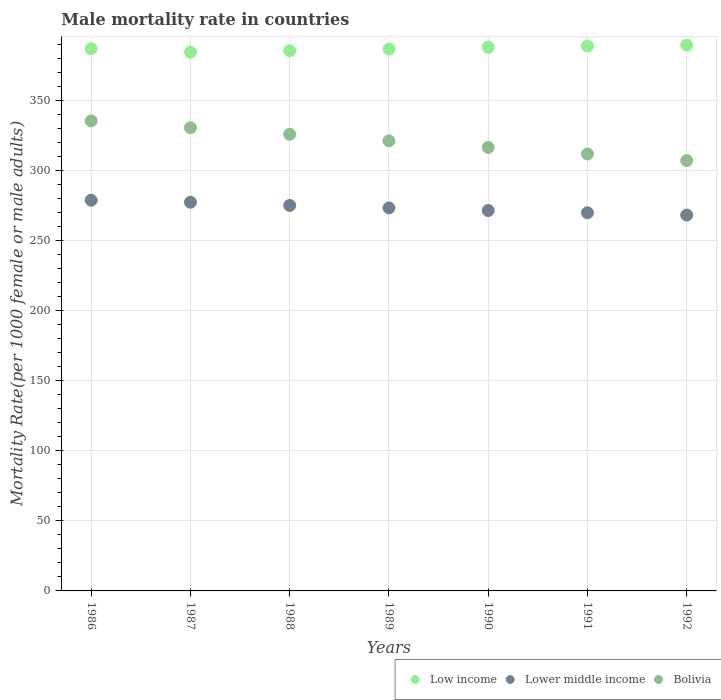Is the number of dotlines equal to the number of legend labels?
Keep it short and to the point. Yes. What is the male mortality rate in Lower middle income in 1986?
Your answer should be compact. 278.89. Across all years, what is the maximum male mortality rate in Bolivia?
Provide a short and direct response. 335.51. Across all years, what is the minimum male mortality rate in Bolivia?
Ensure brevity in your answer.  307.18. What is the total male mortality rate in Lower middle income in the graph?
Provide a succinct answer. 1914.64. What is the difference between the male mortality rate in Lower middle income in 1990 and that in 1991?
Offer a very short reply. 1.62. What is the difference between the male mortality rate in Lower middle income in 1988 and the male mortality rate in Bolivia in 1990?
Make the answer very short. -41.44. What is the average male mortality rate in Lower middle income per year?
Provide a short and direct response. 273.52. In the year 1988, what is the difference between the male mortality rate in Lower middle income and male mortality rate in Low income?
Offer a very short reply. -110.45. What is the ratio of the male mortality rate in Bolivia in 1986 to that in 1991?
Offer a terse response. 1.08. Is the male mortality rate in Low income in 1987 less than that in 1988?
Keep it short and to the point. Yes. Is the difference between the male mortality rate in Lower middle income in 1988 and 1989 greater than the difference between the male mortality rate in Low income in 1988 and 1989?
Provide a succinct answer. Yes. What is the difference between the highest and the second highest male mortality rate in Low income?
Offer a very short reply. 0.69. What is the difference between the highest and the lowest male mortality rate in Bolivia?
Keep it short and to the point. 28.33. Is the sum of the male mortality rate in Low income in 1987 and 1992 greater than the maximum male mortality rate in Bolivia across all years?
Keep it short and to the point. Yes. Is it the case that in every year, the sum of the male mortality rate in Bolivia and male mortality rate in Lower middle income  is greater than the male mortality rate in Low income?
Your response must be concise. Yes. Is the male mortality rate in Bolivia strictly less than the male mortality rate in Low income over the years?
Ensure brevity in your answer.  Yes. How many years are there in the graph?
Your answer should be compact. 7. What is the difference between two consecutive major ticks on the Y-axis?
Your answer should be very brief. 50. Are the values on the major ticks of Y-axis written in scientific E-notation?
Your answer should be compact. No. Does the graph contain any zero values?
Offer a terse response. No. Does the graph contain grids?
Provide a succinct answer. Yes. What is the title of the graph?
Ensure brevity in your answer.  Male mortality rate in countries. Does "Tonga" appear as one of the legend labels in the graph?
Give a very brief answer. No. What is the label or title of the Y-axis?
Offer a terse response. Mortality Rate(per 1000 female or male adults). What is the Mortality Rate(per 1000 female or male adults) in Low income in 1986?
Make the answer very short. 386.95. What is the Mortality Rate(per 1000 female or male adults) of Lower middle income in 1986?
Offer a very short reply. 278.89. What is the Mortality Rate(per 1000 female or male adults) in Bolivia in 1986?
Offer a very short reply. 335.51. What is the Mortality Rate(per 1000 female or male adults) of Low income in 1987?
Your response must be concise. 384.53. What is the Mortality Rate(per 1000 female or male adults) in Lower middle income in 1987?
Your answer should be compact. 277.45. What is the Mortality Rate(per 1000 female or male adults) of Bolivia in 1987?
Provide a succinct answer. 330.66. What is the Mortality Rate(per 1000 female or male adults) in Low income in 1988?
Your answer should be very brief. 385.59. What is the Mortality Rate(per 1000 female or male adults) in Lower middle income in 1988?
Provide a succinct answer. 275.14. What is the Mortality Rate(per 1000 female or male adults) of Bolivia in 1988?
Provide a succinct answer. 325.96. What is the Mortality Rate(per 1000 female or male adults) of Low income in 1989?
Offer a terse response. 386.79. What is the Mortality Rate(per 1000 female or male adults) of Lower middle income in 1989?
Your answer should be compact. 273.4. What is the Mortality Rate(per 1000 female or male adults) in Bolivia in 1989?
Your answer should be very brief. 321.27. What is the Mortality Rate(per 1000 female or male adults) in Low income in 1990?
Ensure brevity in your answer.  388.08. What is the Mortality Rate(per 1000 female or male adults) in Lower middle income in 1990?
Give a very brief answer. 271.54. What is the Mortality Rate(per 1000 female or male adults) in Bolivia in 1990?
Your response must be concise. 316.57. What is the Mortality Rate(per 1000 female or male adults) of Low income in 1991?
Ensure brevity in your answer.  388.94. What is the Mortality Rate(per 1000 female or male adults) of Lower middle income in 1991?
Offer a very short reply. 269.92. What is the Mortality Rate(per 1000 female or male adults) in Bolivia in 1991?
Your answer should be very brief. 311.88. What is the Mortality Rate(per 1000 female or male adults) in Low income in 1992?
Your response must be concise. 389.63. What is the Mortality Rate(per 1000 female or male adults) of Lower middle income in 1992?
Your response must be concise. 268.3. What is the Mortality Rate(per 1000 female or male adults) of Bolivia in 1992?
Offer a terse response. 307.18. Across all years, what is the maximum Mortality Rate(per 1000 female or male adults) in Low income?
Provide a succinct answer. 389.63. Across all years, what is the maximum Mortality Rate(per 1000 female or male adults) of Lower middle income?
Provide a succinct answer. 278.89. Across all years, what is the maximum Mortality Rate(per 1000 female or male adults) of Bolivia?
Provide a succinct answer. 335.51. Across all years, what is the minimum Mortality Rate(per 1000 female or male adults) in Low income?
Offer a terse response. 384.53. Across all years, what is the minimum Mortality Rate(per 1000 female or male adults) of Lower middle income?
Your response must be concise. 268.3. Across all years, what is the minimum Mortality Rate(per 1000 female or male adults) in Bolivia?
Give a very brief answer. 307.18. What is the total Mortality Rate(per 1000 female or male adults) in Low income in the graph?
Offer a terse response. 2710.5. What is the total Mortality Rate(per 1000 female or male adults) in Lower middle income in the graph?
Offer a terse response. 1914.64. What is the total Mortality Rate(per 1000 female or male adults) of Bolivia in the graph?
Your response must be concise. 2249.03. What is the difference between the Mortality Rate(per 1000 female or male adults) in Low income in 1986 and that in 1987?
Provide a short and direct response. 2.41. What is the difference between the Mortality Rate(per 1000 female or male adults) of Lower middle income in 1986 and that in 1987?
Offer a very short reply. 1.44. What is the difference between the Mortality Rate(per 1000 female or male adults) of Bolivia in 1986 and that in 1987?
Your answer should be very brief. 4.86. What is the difference between the Mortality Rate(per 1000 female or male adults) in Low income in 1986 and that in 1988?
Offer a very short reply. 1.36. What is the difference between the Mortality Rate(per 1000 female or male adults) of Lower middle income in 1986 and that in 1988?
Your response must be concise. 3.75. What is the difference between the Mortality Rate(per 1000 female or male adults) of Bolivia in 1986 and that in 1988?
Provide a succinct answer. 9.55. What is the difference between the Mortality Rate(per 1000 female or male adults) of Low income in 1986 and that in 1989?
Your answer should be compact. 0.16. What is the difference between the Mortality Rate(per 1000 female or male adults) of Lower middle income in 1986 and that in 1989?
Give a very brief answer. 5.49. What is the difference between the Mortality Rate(per 1000 female or male adults) of Bolivia in 1986 and that in 1989?
Your answer should be very brief. 14.24. What is the difference between the Mortality Rate(per 1000 female or male adults) in Low income in 1986 and that in 1990?
Give a very brief answer. -1.13. What is the difference between the Mortality Rate(per 1000 female or male adults) in Lower middle income in 1986 and that in 1990?
Your response must be concise. 7.35. What is the difference between the Mortality Rate(per 1000 female or male adults) in Bolivia in 1986 and that in 1990?
Give a very brief answer. 18.94. What is the difference between the Mortality Rate(per 1000 female or male adults) in Low income in 1986 and that in 1991?
Your response must be concise. -1.99. What is the difference between the Mortality Rate(per 1000 female or male adults) in Lower middle income in 1986 and that in 1991?
Your answer should be very brief. 8.96. What is the difference between the Mortality Rate(per 1000 female or male adults) of Bolivia in 1986 and that in 1991?
Offer a very short reply. 23.63. What is the difference between the Mortality Rate(per 1000 female or male adults) in Low income in 1986 and that in 1992?
Make the answer very short. -2.68. What is the difference between the Mortality Rate(per 1000 female or male adults) in Lower middle income in 1986 and that in 1992?
Give a very brief answer. 10.59. What is the difference between the Mortality Rate(per 1000 female or male adults) of Bolivia in 1986 and that in 1992?
Your response must be concise. 28.33. What is the difference between the Mortality Rate(per 1000 female or male adults) of Low income in 1987 and that in 1988?
Make the answer very short. -1.05. What is the difference between the Mortality Rate(per 1000 female or male adults) of Lower middle income in 1987 and that in 1988?
Offer a very short reply. 2.31. What is the difference between the Mortality Rate(per 1000 female or male adults) in Bolivia in 1987 and that in 1988?
Provide a succinct answer. 4.7. What is the difference between the Mortality Rate(per 1000 female or male adults) in Low income in 1987 and that in 1989?
Offer a very short reply. -2.26. What is the difference between the Mortality Rate(per 1000 female or male adults) in Lower middle income in 1987 and that in 1989?
Offer a terse response. 4.05. What is the difference between the Mortality Rate(per 1000 female or male adults) of Bolivia in 1987 and that in 1989?
Keep it short and to the point. 9.39. What is the difference between the Mortality Rate(per 1000 female or male adults) of Low income in 1987 and that in 1990?
Offer a terse response. -3.54. What is the difference between the Mortality Rate(per 1000 female or male adults) of Lower middle income in 1987 and that in 1990?
Make the answer very short. 5.9. What is the difference between the Mortality Rate(per 1000 female or male adults) in Bolivia in 1987 and that in 1990?
Offer a terse response. 14.08. What is the difference between the Mortality Rate(per 1000 female or male adults) in Low income in 1987 and that in 1991?
Keep it short and to the point. -4.4. What is the difference between the Mortality Rate(per 1000 female or male adults) in Lower middle income in 1987 and that in 1991?
Your answer should be very brief. 7.52. What is the difference between the Mortality Rate(per 1000 female or male adults) in Bolivia in 1987 and that in 1991?
Your answer should be very brief. 18.78. What is the difference between the Mortality Rate(per 1000 female or male adults) in Low income in 1987 and that in 1992?
Provide a succinct answer. -5.09. What is the difference between the Mortality Rate(per 1000 female or male adults) in Lower middle income in 1987 and that in 1992?
Your response must be concise. 9.14. What is the difference between the Mortality Rate(per 1000 female or male adults) in Bolivia in 1987 and that in 1992?
Provide a succinct answer. 23.47. What is the difference between the Mortality Rate(per 1000 female or male adults) of Low income in 1988 and that in 1989?
Offer a terse response. -1.2. What is the difference between the Mortality Rate(per 1000 female or male adults) in Lower middle income in 1988 and that in 1989?
Give a very brief answer. 1.74. What is the difference between the Mortality Rate(per 1000 female or male adults) in Bolivia in 1988 and that in 1989?
Make the answer very short. 4.69. What is the difference between the Mortality Rate(per 1000 female or male adults) in Low income in 1988 and that in 1990?
Your answer should be compact. -2.49. What is the difference between the Mortality Rate(per 1000 female or male adults) in Lower middle income in 1988 and that in 1990?
Offer a very short reply. 3.59. What is the difference between the Mortality Rate(per 1000 female or male adults) of Bolivia in 1988 and that in 1990?
Provide a succinct answer. 9.39. What is the difference between the Mortality Rate(per 1000 female or male adults) in Low income in 1988 and that in 1991?
Give a very brief answer. -3.35. What is the difference between the Mortality Rate(per 1000 female or male adults) in Lower middle income in 1988 and that in 1991?
Keep it short and to the point. 5.21. What is the difference between the Mortality Rate(per 1000 female or male adults) in Bolivia in 1988 and that in 1991?
Provide a succinct answer. 14.08. What is the difference between the Mortality Rate(per 1000 female or male adults) in Low income in 1988 and that in 1992?
Give a very brief answer. -4.04. What is the difference between the Mortality Rate(per 1000 female or male adults) in Lower middle income in 1988 and that in 1992?
Provide a succinct answer. 6.83. What is the difference between the Mortality Rate(per 1000 female or male adults) of Bolivia in 1988 and that in 1992?
Make the answer very short. 18.78. What is the difference between the Mortality Rate(per 1000 female or male adults) in Low income in 1989 and that in 1990?
Keep it short and to the point. -1.28. What is the difference between the Mortality Rate(per 1000 female or male adults) in Lower middle income in 1989 and that in 1990?
Your answer should be compact. 1.86. What is the difference between the Mortality Rate(per 1000 female or male adults) of Bolivia in 1989 and that in 1990?
Offer a terse response. 4.69. What is the difference between the Mortality Rate(per 1000 female or male adults) of Low income in 1989 and that in 1991?
Offer a very short reply. -2.15. What is the difference between the Mortality Rate(per 1000 female or male adults) of Lower middle income in 1989 and that in 1991?
Keep it short and to the point. 3.48. What is the difference between the Mortality Rate(per 1000 female or male adults) of Bolivia in 1989 and that in 1991?
Your answer should be compact. 9.39. What is the difference between the Mortality Rate(per 1000 female or male adults) of Low income in 1989 and that in 1992?
Ensure brevity in your answer.  -2.84. What is the difference between the Mortality Rate(per 1000 female or male adults) of Lower middle income in 1989 and that in 1992?
Ensure brevity in your answer.  5.1. What is the difference between the Mortality Rate(per 1000 female or male adults) of Bolivia in 1989 and that in 1992?
Provide a short and direct response. 14.08. What is the difference between the Mortality Rate(per 1000 female or male adults) of Low income in 1990 and that in 1991?
Your answer should be compact. -0.86. What is the difference between the Mortality Rate(per 1000 female or male adults) in Lower middle income in 1990 and that in 1991?
Keep it short and to the point. 1.62. What is the difference between the Mortality Rate(per 1000 female or male adults) in Bolivia in 1990 and that in 1991?
Offer a terse response. 4.7. What is the difference between the Mortality Rate(per 1000 female or male adults) of Low income in 1990 and that in 1992?
Make the answer very short. -1.55. What is the difference between the Mortality Rate(per 1000 female or male adults) of Lower middle income in 1990 and that in 1992?
Give a very brief answer. 3.24. What is the difference between the Mortality Rate(per 1000 female or male adults) of Bolivia in 1990 and that in 1992?
Ensure brevity in your answer.  9.39. What is the difference between the Mortality Rate(per 1000 female or male adults) in Low income in 1991 and that in 1992?
Your answer should be compact. -0.69. What is the difference between the Mortality Rate(per 1000 female or male adults) of Lower middle income in 1991 and that in 1992?
Your response must be concise. 1.62. What is the difference between the Mortality Rate(per 1000 female or male adults) in Bolivia in 1991 and that in 1992?
Your response must be concise. 4.69. What is the difference between the Mortality Rate(per 1000 female or male adults) of Low income in 1986 and the Mortality Rate(per 1000 female or male adults) of Lower middle income in 1987?
Offer a terse response. 109.5. What is the difference between the Mortality Rate(per 1000 female or male adults) of Low income in 1986 and the Mortality Rate(per 1000 female or male adults) of Bolivia in 1987?
Offer a terse response. 56.29. What is the difference between the Mortality Rate(per 1000 female or male adults) of Lower middle income in 1986 and the Mortality Rate(per 1000 female or male adults) of Bolivia in 1987?
Your response must be concise. -51.77. What is the difference between the Mortality Rate(per 1000 female or male adults) of Low income in 1986 and the Mortality Rate(per 1000 female or male adults) of Lower middle income in 1988?
Offer a very short reply. 111.81. What is the difference between the Mortality Rate(per 1000 female or male adults) in Low income in 1986 and the Mortality Rate(per 1000 female or male adults) in Bolivia in 1988?
Ensure brevity in your answer.  60.99. What is the difference between the Mortality Rate(per 1000 female or male adults) of Lower middle income in 1986 and the Mortality Rate(per 1000 female or male adults) of Bolivia in 1988?
Give a very brief answer. -47.07. What is the difference between the Mortality Rate(per 1000 female or male adults) in Low income in 1986 and the Mortality Rate(per 1000 female or male adults) in Lower middle income in 1989?
Keep it short and to the point. 113.55. What is the difference between the Mortality Rate(per 1000 female or male adults) of Low income in 1986 and the Mortality Rate(per 1000 female or male adults) of Bolivia in 1989?
Ensure brevity in your answer.  65.68. What is the difference between the Mortality Rate(per 1000 female or male adults) of Lower middle income in 1986 and the Mortality Rate(per 1000 female or male adults) of Bolivia in 1989?
Your answer should be very brief. -42.38. What is the difference between the Mortality Rate(per 1000 female or male adults) of Low income in 1986 and the Mortality Rate(per 1000 female or male adults) of Lower middle income in 1990?
Your answer should be very brief. 115.41. What is the difference between the Mortality Rate(per 1000 female or male adults) of Low income in 1986 and the Mortality Rate(per 1000 female or male adults) of Bolivia in 1990?
Keep it short and to the point. 70.38. What is the difference between the Mortality Rate(per 1000 female or male adults) in Lower middle income in 1986 and the Mortality Rate(per 1000 female or male adults) in Bolivia in 1990?
Offer a very short reply. -37.68. What is the difference between the Mortality Rate(per 1000 female or male adults) in Low income in 1986 and the Mortality Rate(per 1000 female or male adults) in Lower middle income in 1991?
Your answer should be very brief. 117.02. What is the difference between the Mortality Rate(per 1000 female or male adults) in Low income in 1986 and the Mortality Rate(per 1000 female or male adults) in Bolivia in 1991?
Your response must be concise. 75.07. What is the difference between the Mortality Rate(per 1000 female or male adults) of Lower middle income in 1986 and the Mortality Rate(per 1000 female or male adults) of Bolivia in 1991?
Keep it short and to the point. -32.99. What is the difference between the Mortality Rate(per 1000 female or male adults) of Low income in 1986 and the Mortality Rate(per 1000 female or male adults) of Lower middle income in 1992?
Keep it short and to the point. 118.65. What is the difference between the Mortality Rate(per 1000 female or male adults) in Low income in 1986 and the Mortality Rate(per 1000 female or male adults) in Bolivia in 1992?
Ensure brevity in your answer.  79.77. What is the difference between the Mortality Rate(per 1000 female or male adults) in Lower middle income in 1986 and the Mortality Rate(per 1000 female or male adults) in Bolivia in 1992?
Ensure brevity in your answer.  -28.3. What is the difference between the Mortality Rate(per 1000 female or male adults) of Low income in 1987 and the Mortality Rate(per 1000 female or male adults) of Lower middle income in 1988?
Your answer should be compact. 109.4. What is the difference between the Mortality Rate(per 1000 female or male adults) of Low income in 1987 and the Mortality Rate(per 1000 female or male adults) of Bolivia in 1988?
Provide a short and direct response. 58.57. What is the difference between the Mortality Rate(per 1000 female or male adults) in Lower middle income in 1987 and the Mortality Rate(per 1000 female or male adults) in Bolivia in 1988?
Your response must be concise. -48.51. What is the difference between the Mortality Rate(per 1000 female or male adults) in Low income in 1987 and the Mortality Rate(per 1000 female or male adults) in Lower middle income in 1989?
Give a very brief answer. 111.13. What is the difference between the Mortality Rate(per 1000 female or male adults) in Low income in 1987 and the Mortality Rate(per 1000 female or male adults) in Bolivia in 1989?
Your response must be concise. 63.27. What is the difference between the Mortality Rate(per 1000 female or male adults) in Lower middle income in 1987 and the Mortality Rate(per 1000 female or male adults) in Bolivia in 1989?
Make the answer very short. -43.82. What is the difference between the Mortality Rate(per 1000 female or male adults) in Low income in 1987 and the Mortality Rate(per 1000 female or male adults) in Lower middle income in 1990?
Offer a terse response. 112.99. What is the difference between the Mortality Rate(per 1000 female or male adults) in Low income in 1987 and the Mortality Rate(per 1000 female or male adults) in Bolivia in 1990?
Provide a short and direct response. 67.96. What is the difference between the Mortality Rate(per 1000 female or male adults) in Lower middle income in 1987 and the Mortality Rate(per 1000 female or male adults) in Bolivia in 1990?
Ensure brevity in your answer.  -39.13. What is the difference between the Mortality Rate(per 1000 female or male adults) of Low income in 1987 and the Mortality Rate(per 1000 female or male adults) of Lower middle income in 1991?
Your response must be concise. 114.61. What is the difference between the Mortality Rate(per 1000 female or male adults) of Low income in 1987 and the Mortality Rate(per 1000 female or male adults) of Bolivia in 1991?
Offer a terse response. 72.66. What is the difference between the Mortality Rate(per 1000 female or male adults) of Lower middle income in 1987 and the Mortality Rate(per 1000 female or male adults) of Bolivia in 1991?
Offer a terse response. -34.43. What is the difference between the Mortality Rate(per 1000 female or male adults) in Low income in 1987 and the Mortality Rate(per 1000 female or male adults) in Lower middle income in 1992?
Provide a short and direct response. 116.23. What is the difference between the Mortality Rate(per 1000 female or male adults) in Low income in 1987 and the Mortality Rate(per 1000 female or male adults) in Bolivia in 1992?
Make the answer very short. 77.35. What is the difference between the Mortality Rate(per 1000 female or male adults) in Lower middle income in 1987 and the Mortality Rate(per 1000 female or male adults) in Bolivia in 1992?
Your answer should be very brief. -29.74. What is the difference between the Mortality Rate(per 1000 female or male adults) of Low income in 1988 and the Mortality Rate(per 1000 female or male adults) of Lower middle income in 1989?
Make the answer very short. 112.19. What is the difference between the Mortality Rate(per 1000 female or male adults) of Low income in 1988 and the Mortality Rate(per 1000 female or male adults) of Bolivia in 1989?
Ensure brevity in your answer.  64.32. What is the difference between the Mortality Rate(per 1000 female or male adults) of Lower middle income in 1988 and the Mortality Rate(per 1000 female or male adults) of Bolivia in 1989?
Offer a very short reply. -46.13. What is the difference between the Mortality Rate(per 1000 female or male adults) in Low income in 1988 and the Mortality Rate(per 1000 female or male adults) in Lower middle income in 1990?
Your answer should be very brief. 114.05. What is the difference between the Mortality Rate(per 1000 female or male adults) in Low income in 1988 and the Mortality Rate(per 1000 female or male adults) in Bolivia in 1990?
Offer a terse response. 69.02. What is the difference between the Mortality Rate(per 1000 female or male adults) of Lower middle income in 1988 and the Mortality Rate(per 1000 female or male adults) of Bolivia in 1990?
Offer a terse response. -41.44. What is the difference between the Mortality Rate(per 1000 female or male adults) in Low income in 1988 and the Mortality Rate(per 1000 female or male adults) in Lower middle income in 1991?
Your answer should be compact. 115.66. What is the difference between the Mortality Rate(per 1000 female or male adults) of Low income in 1988 and the Mortality Rate(per 1000 female or male adults) of Bolivia in 1991?
Your answer should be very brief. 73.71. What is the difference between the Mortality Rate(per 1000 female or male adults) in Lower middle income in 1988 and the Mortality Rate(per 1000 female or male adults) in Bolivia in 1991?
Keep it short and to the point. -36.74. What is the difference between the Mortality Rate(per 1000 female or male adults) of Low income in 1988 and the Mortality Rate(per 1000 female or male adults) of Lower middle income in 1992?
Provide a short and direct response. 117.29. What is the difference between the Mortality Rate(per 1000 female or male adults) in Low income in 1988 and the Mortality Rate(per 1000 female or male adults) in Bolivia in 1992?
Your answer should be compact. 78.4. What is the difference between the Mortality Rate(per 1000 female or male adults) in Lower middle income in 1988 and the Mortality Rate(per 1000 female or male adults) in Bolivia in 1992?
Provide a succinct answer. -32.05. What is the difference between the Mortality Rate(per 1000 female or male adults) in Low income in 1989 and the Mortality Rate(per 1000 female or male adults) in Lower middle income in 1990?
Offer a very short reply. 115.25. What is the difference between the Mortality Rate(per 1000 female or male adults) of Low income in 1989 and the Mortality Rate(per 1000 female or male adults) of Bolivia in 1990?
Your answer should be compact. 70.22. What is the difference between the Mortality Rate(per 1000 female or male adults) of Lower middle income in 1989 and the Mortality Rate(per 1000 female or male adults) of Bolivia in 1990?
Your answer should be very brief. -43.17. What is the difference between the Mortality Rate(per 1000 female or male adults) of Low income in 1989 and the Mortality Rate(per 1000 female or male adults) of Lower middle income in 1991?
Give a very brief answer. 116.87. What is the difference between the Mortality Rate(per 1000 female or male adults) in Low income in 1989 and the Mortality Rate(per 1000 female or male adults) in Bolivia in 1991?
Your answer should be compact. 74.91. What is the difference between the Mortality Rate(per 1000 female or male adults) in Lower middle income in 1989 and the Mortality Rate(per 1000 female or male adults) in Bolivia in 1991?
Make the answer very short. -38.48. What is the difference between the Mortality Rate(per 1000 female or male adults) in Low income in 1989 and the Mortality Rate(per 1000 female or male adults) in Lower middle income in 1992?
Give a very brief answer. 118.49. What is the difference between the Mortality Rate(per 1000 female or male adults) in Low income in 1989 and the Mortality Rate(per 1000 female or male adults) in Bolivia in 1992?
Offer a very short reply. 79.61. What is the difference between the Mortality Rate(per 1000 female or male adults) in Lower middle income in 1989 and the Mortality Rate(per 1000 female or male adults) in Bolivia in 1992?
Provide a succinct answer. -33.78. What is the difference between the Mortality Rate(per 1000 female or male adults) in Low income in 1990 and the Mortality Rate(per 1000 female or male adults) in Lower middle income in 1991?
Make the answer very short. 118.15. What is the difference between the Mortality Rate(per 1000 female or male adults) of Low income in 1990 and the Mortality Rate(per 1000 female or male adults) of Bolivia in 1991?
Provide a succinct answer. 76.2. What is the difference between the Mortality Rate(per 1000 female or male adults) in Lower middle income in 1990 and the Mortality Rate(per 1000 female or male adults) in Bolivia in 1991?
Give a very brief answer. -40.34. What is the difference between the Mortality Rate(per 1000 female or male adults) of Low income in 1990 and the Mortality Rate(per 1000 female or male adults) of Lower middle income in 1992?
Your answer should be very brief. 119.77. What is the difference between the Mortality Rate(per 1000 female or male adults) in Low income in 1990 and the Mortality Rate(per 1000 female or male adults) in Bolivia in 1992?
Keep it short and to the point. 80.89. What is the difference between the Mortality Rate(per 1000 female or male adults) in Lower middle income in 1990 and the Mortality Rate(per 1000 female or male adults) in Bolivia in 1992?
Your answer should be compact. -35.64. What is the difference between the Mortality Rate(per 1000 female or male adults) of Low income in 1991 and the Mortality Rate(per 1000 female or male adults) of Lower middle income in 1992?
Offer a terse response. 120.64. What is the difference between the Mortality Rate(per 1000 female or male adults) in Low income in 1991 and the Mortality Rate(per 1000 female or male adults) in Bolivia in 1992?
Keep it short and to the point. 81.75. What is the difference between the Mortality Rate(per 1000 female or male adults) in Lower middle income in 1991 and the Mortality Rate(per 1000 female or male adults) in Bolivia in 1992?
Keep it short and to the point. -37.26. What is the average Mortality Rate(per 1000 female or male adults) in Low income per year?
Your answer should be compact. 387.21. What is the average Mortality Rate(per 1000 female or male adults) of Lower middle income per year?
Offer a very short reply. 273.52. What is the average Mortality Rate(per 1000 female or male adults) of Bolivia per year?
Provide a short and direct response. 321.29. In the year 1986, what is the difference between the Mortality Rate(per 1000 female or male adults) of Low income and Mortality Rate(per 1000 female or male adults) of Lower middle income?
Offer a very short reply. 108.06. In the year 1986, what is the difference between the Mortality Rate(per 1000 female or male adults) of Low income and Mortality Rate(per 1000 female or male adults) of Bolivia?
Provide a short and direct response. 51.44. In the year 1986, what is the difference between the Mortality Rate(per 1000 female or male adults) in Lower middle income and Mortality Rate(per 1000 female or male adults) in Bolivia?
Give a very brief answer. -56.62. In the year 1987, what is the difference between the Mortality Rate(per 1000 female or male adults) in Low income and Mortality Rate(per 1000 female or male adults) in Lower middle income?
Provide a succinct answer. 107.09. In the year 1987, what is the difference between the Mortality Rate(per 1000 female or male adults) in Low income and Mortality Rate(per 1000 female or male adults) in Bolivia?
Offer a very short reply. 53.88. In the year 1987, what is the difference between the Mortality Rate(per 1000 female or male adults) in Lower middle income and Mortality Rate(per 1000 female or male adults) in Bolivia?
Keep it short and to the point. -53.21. In the year 1988, what is the difference between the Mortality Rate(per 1000 female or male adults) in Low income and Mortality Rate(per 1000 female or male adults) in Lower middle income?
Give a very brief answer. 110.45. In the year 1988, what is the difference between the Mortality Rate(per 1000 female or male adults) of Low income and Mortality Rate(per 1000 female or male adults) of Bolivia?
Keep it short and to the point. 59.63. In the year 1988, what is the difference between the Mortality Rate(per 1000 female or male adults) in Lower middle income and Mortality Rate(per 1000 female or male adults) in Bolivia?
Your answer should be very brief. -50.82. In the year 1989, what is the difference between the Mortality Rate(per 1000 female or male adults) in Low income and Mortality Rate(per 1000 female or male adults) in Lower middle income?
Your answer should be compact. 113.39. In the year 1989, what is the difference between the Mortality Rate(per 1000 female or male adults) of Low income and Mortality Rate(per 1000 female or male adults) of Bolivia?
Your answer should be very brief. 65.52. In the year 1989, what is the difference between the Mortality Rate(per 1000 female or male adults) of Lower middle income and Mortality Rate(per 1000 female or male adults) of Bolivia?
Your answer should be very brief. -47.87. In the year 1990, what is the difference between the Mortality Rate(per 1000 female or male adults) of Low income and Mortality Rate(per 1000 female or male adults) of Lower middle income?
Give a very brief answer. 116.53. In the year 1990, what is the difference between the Mortality Rate(per 1000 female or male adults) in Low income and Mortality Rate(per 1000 female or male adults) in Bolivia?
Offer a very short reply. 71.5. In the year 1990, what is the difference between the Mortality Rate(per 1000 female or male adults) of Lower middle income and Mortality Rate(per 1000 female or male adults) of Bolivia?
Your response must be concise. -45.03. In the year 1991, what is the difference between the Mortality Rate(per 1000 female or male adults) in Low income and Mortality Rate(per 1000 female or male adults) in Lower middle income?
Offer a terse response. 119.01. In the year 1991, what is the difference between the Mortality Rate(per 1000 female or male adults) of Low income and Mortality Rate(per 1000 female or male adults) of Bolivia?
Keep it short and to the point. 77.06. In the year 1991, what is the difference between the Mortality Rate(per 1000 female or male adults) in Lower middle income and Mortality Rate(per 1000 female or male adults) in Bolivia?
Offer a very short reply. -41.95. In the year 1992, what is the difference between the Mortality Rate(per 1000 female or male adults) in Low income and Mortality Rate(per 1000 female or male adults) in Lower middle income?
Offer a terse response. 121.32. In the year 1992, what is the difference between the Mortality Rate(per 1000 female or male adults) in Low income and Mortality Rate(per 1000 female or male adults) in Bolivia?
Your response must be concise. 82.44. In the year 1992, what is the difference between the Mortality Rate(per 1000 female or male adults) of Lower middle income and Mortality Rate(per 1000 female or male adults) of Bolivia?
Your response must be concise. -38.88. What is the ratio of the Mortality Rate(per 1000 female or male adults) in Low income in 1986 to that in 1987?
Ensure brevity in your answer.  1.01. What is the ratio of the Mortality Rate(per 1000 female or male adults) of Bolivia in 1986 to that in 1987?
Your answer should be very brief. 1.01. What is the ratio of the Mortality Rate(per 1000 female or male adults) in Low income in 1986 to that in 1988?
Offer a terse response. 1. What is the ratio of the Mortality Rate(per 1000 female or male adults) of Lower middle income in 1986 to that in 1988?
Ensure brevity in your answer.  1.01. What is the ratio of the Mortality Rate(per 1000 female or male adults) of Bolivia in 1986 to that in 1988?
Give a very brief answer. 1.03. What is the ratio of the Mortality Rate(per 1000 female or male adults) of Lower middle income in 1986 to that in 1989?
Keep it short and to the point. 1.02. What is the ratio of the Mortality Rate(per 1000 female or male adults) in Bolivia in 1986 to that in 1989?
Your response must be concise. 1.04. What is the ratio of the Mortality Rate(per 1000 female or male adults) in Low income in 1986 to that in 1990?
Provide a succinct answer. 1. What is the ratio of the Mortality Rate(per 1000 female or male adults) of Lower middle income in 1986 to that in 1990?
Provide a short and direct response. 1.03. What is the ratio of the Mortality Rate(per 1000 female or male adults) in Bolivia in 1986 to that in 1990?
Your answer should be compact. 1.06. What is the ratio of the Mortality Rate(per 1000 female or male adults) in Low income in 1986 to that in 1991?
Your answer should be very brief. 0.99. What is the ratio of the Mortality Rate(per 1000 female or male adults) in Lower middle income in 1986 to that in 1991?
Your response must be concise. 1.03. What is the ratio of the Mortality Rate(per 1000 female or male adults) of Bolivia in 1986 to that in 1991?
Offer a terse response. 1.08. What is the ratio of the Mortality Rate(per 1000 female or male adults) in Lower middle income in 1986 to that in 1992?
Offer a very short reply. 1.04. What is the ratio of the Mortality Rate(per 1000 female or male adults) of Bolivia in 1986 to that in 1992?
Ensure brevity in your answer.  1.09. What is the ratio of the Mortality Rate(per 1000 female or male adults) of Low income in 1987 to that in 1988?
Ensure brevity in your answer.  1. What is the ratio of the Mortality Rate(per 1000 female or male adults) of Lower middle income in 1987 to that in 1988?
Offer a terse response. 1.01. What is the ratio of the Mortality Rate(per 1000 female or male adults) of Bolivia in 1987 to that in 1988?
Your answer should be very brief. 1.01. What is the ratio of the Mortality Rate(per 1000 female or male adults) in Low income in 1987 to that in 1989?
Your response must be concise. 0.99. What is the ratio of the Mortality Rate(per 1000 female or male adults) in Lower middle income in 1987 to that in 1989?
Make the answer very short. 1.01. What is the ratio of the Mortality Rate(per 1000 female or male adults) of Bolivia in 1987 to that in 1989?
Offer a terse response. 1.03. What is the ratio of the Mortality Rate(per 1000 female or male adults) in Low income in 1987 to that in 1990?
Give a very brief answer. 0.99. What is the ratio of the Mortality Rate(per 1000 female or male adults) of Lower middle income in 1987 to that in 1990?
Your answer should be compact. 1.02. What is the ratio of the Mortality Rate(per 1000 female or male adults) of Bolivia in 1987 to that in 1990?
Offer a terse response. 1.04. What is the ratio of the Mortality Rate(per 1000 female or male adults) of Low income in 1987 to that in 1991?
Your answer should be compact. 0.99. What is the ratio of the Mortality Rate(per 1000 female or male adults) of Lower middle income in 1987 to that in 1991?
Provide a succinct answer. 1.03. What is the ratio of the Mortality Rate(per 1000 female or male adults) of Bolivia in 1987 to that in 1991?
Give a very brief answer. 1.06. What is the ratio of the Mortality Rate(per 1000 female or male adults) of Low income in 1987 to that in 1992?
Keep it short and to the point. 0.99. What is the ratio of the Mortality Rate(per 1000 female or male adults) in Lower middle income in 1987 to that in 1992?
Your response must be concise. 1.03. What is the ratio of the Mortality Rate(per 1000 female or male adults) in Bolivia in 1987 to that in 1992?
Make the answer very short. 1.08. What is the ratio of the Mortality Rate(per 1000 female or male adults) of Low income in 1988 to that in 1989?
Make the answer very short. 1. What is the ratio of the Mortality Rate(per 1000 female or male adults) in Lower middle income in 1988 to that in 1989?
Give a very brief answer. 1.01. What is the ratio of the Mortality Rate(per 1000 female or male adults) of Bolivia in 1988 to that in 1989?
Offer a very short reply. 1.01. What is the ratio of the Mortality Rate(per 1000 female or male adults) in Lower middle income in 1988 to that in 1990?
Your answer should be compact. 1.01. What is the ratio of the Mortality Rate(per 1000 female or male adults) in Bolivia in 1988 to that in 1990?
Offer a very short reply. 1.03. What is the ratio of the Mortality Rate(per 1000 female or male adults) of Lower middle income in 1988 to that in 1991?
Provide a succinct answer. 1.02. What is the ratio of the Mortality Rate(per 1000 female or male adults) in Bolivia in 1988 to that in 1991?
Ensure brevity in your answer.  1.05. What is the ratio of the Mortality Rate(per 1000 female or male adults) in Lower middle income in 1988 to that in 1992?
Ensure brevity in your answer.  1.03. What is the ratio of the Mortality Rate(per 1000 female or male adults) in Bolivia in 1988 to that in 1992?
Your answer should be compact. 1.06. What is the ratio of the Mortality Rate(per 1000 female or male adults) of Low income in 1989 to that in 1990?
Your answer should be compact. 1. What is the ratio of the Mortality Rate(per 1000 female or male adults) in Lower middle income in 1989 to that in 1990?
Give a very brief answer. 1.01. What is the ratio of the Mortality Rate(per 1000 female or male adults) of Bolivia in 1989 to that in 1990?
Your response must be concise. 1.01. What is the ratio of the Mortality Rate(per 1000 female or male adults) of Lower middle income in 1989 to that in 1991?
Your response must be concise. 1.01. What is the ratio of the Mortality Rate(per 1000 female or male adults) in Bolivia in 1989 to that in 1991?
Provide a short and direct response. 1.03. What is the ratio of the Mortality Rate(per 1000 female or male adults) in Lower middle income in 1989 to that in 1992?
Your answer should be compact. 1.02. What is the ratio of the Mortality Rate(per 1000 female or male adults) in Bolivia in 1989 to that in 1992?
Provide a short and direct response. 1.05. What is the ratio of the Mortality Rate(per 1000 female or male adults) of Lower middle income in 1990 to that in 1991?
Your answer should be compact. 1.01. What is the ratio of the Mortality Rate(per 1000 female or male adults) in Bolivia in 1990 to that in 1991?
Make the answer very short. 1.02. What is the ratio of the Mortality Rate(per 1000 female or male adults) in Lower middle income in 1990 to that in 1992?
Provide a short and direct response. 1.01. What is the ratio of the Mortality Rate(per 1000 female or male adults) of Bolivia in 1990 to that in 1992?
Your answer should be compact. 1.03. What is the ratio of the Mortality Rate(per 1000 female or male adults) of Low income in 1991 to that in 1992?
Your answer should be very brief. 1. What is the ratio of the Mortality Rate(per 1000 female or male adults) of Lower middle income in 1991 to that in 1992?
Your answer should be very brief. 1.01. What is the ratio of the Mortality Rate(per 1000 female or male adults) of Bolivia in 1991 to that in 1992?
Offer a terse response. 1.02. What is the difference between the highest and the second highest Mortality Rate(per 1000 female or male adults) in Low income?
Keep it short and to the point. 0.69. What is the difference between the highest and the second highest Mortality Rate(per 1000 female or male adults) in Lower middle income?
Provide a succinct answer. 1.44. What is the difference between the highest and the second highest Mortality Rate(per 1000 female or male adults) of Bolivia?
Your response must be concise. 4.86. What is the difference between the highest and the lowest Mortality Rate(per 1000 female or male adults) of Low income?
Offer a very short reply. 5.09. What is the difference between the highest and the lowest Mortality Rate(per 1000 female or male adults) in Lower middle income?
Ensure brevity in your answer.  10.59. What is the difference between the highest and the lowest Mortality Rate(per 1000 female or male adults) in Bolivia?
Provide a short and direct response. 28.33. 